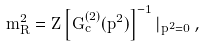<formula> <loc_0><loc_0><loc_500><loc_500>m _ { R } ^ { 2 } = Z \left [ G _ { c } ^ { ( 2 ) } ( p ^ { 2 } ) \right ] ^ { - 1 } | _ { p ^ { 2 } = 0 } \, ,</formula> 